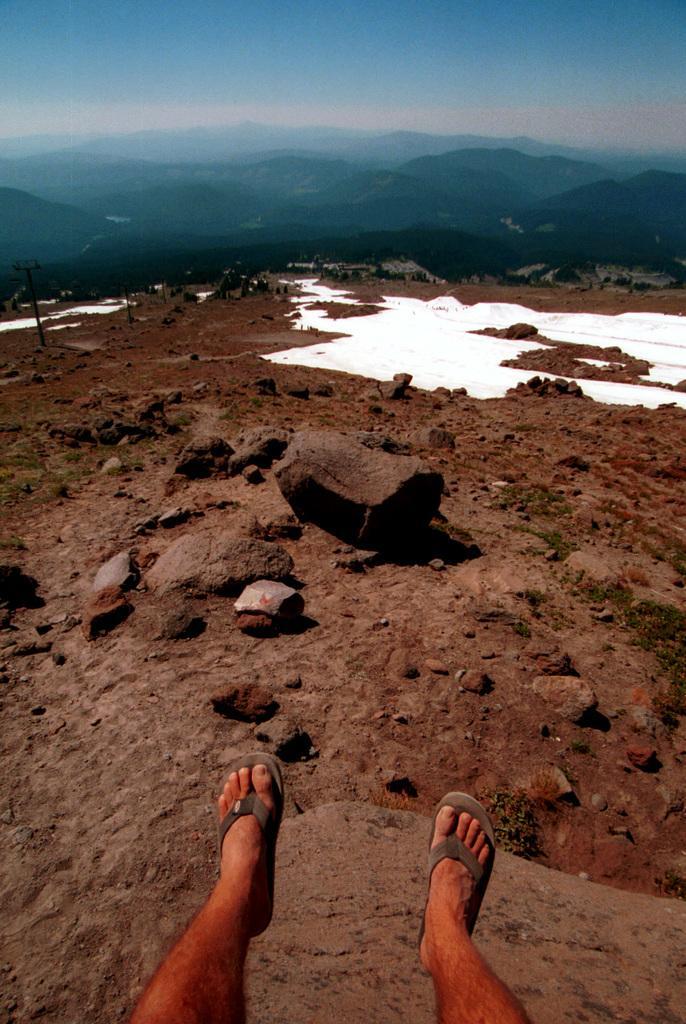Please provide a concise description of this image. Bottom of the image we can see some legs. Behind the legs we can see some stones and hills. In the middle of the image there are some hills. Top of the image there are some clouds and sky. 